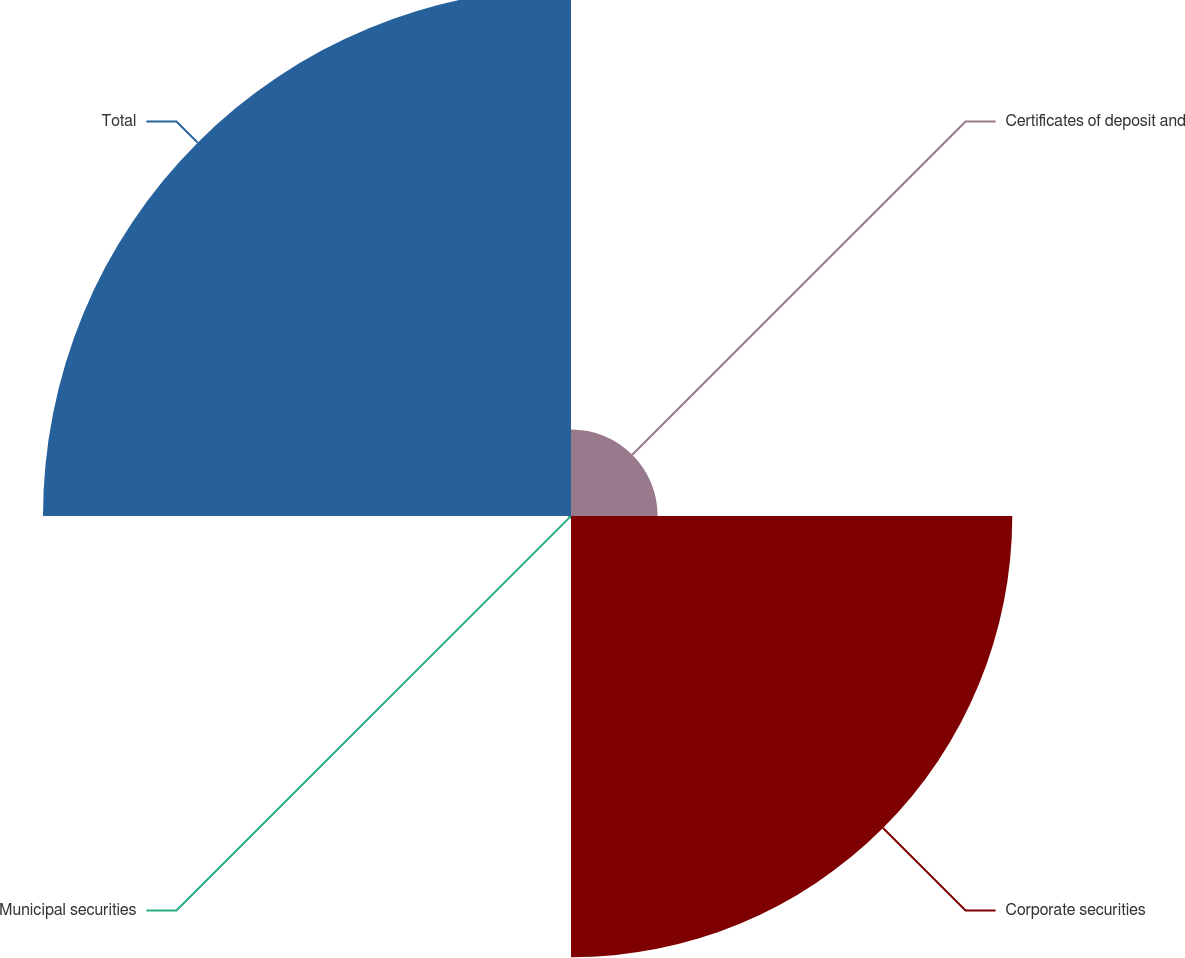Convert chart. <chart><loc_0><loc_0><loc_500><loc_500><pie_chart><fcel>Certificates of deposit and<fcel>Corporate securities<fcel>Municipal securities<fcel>Total<nl><fcel>8.18%<fcel>41.67%<fcel>0.28%<fcel>49.86%<nl></chart> 